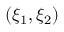<formula> <loc_0><loc_0><loc_500><loc_500>( \xi _ { 1 } , \xi _ { 2 } )</formula> 